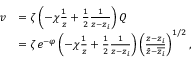<formula> <loc_0><loc_0><loc_500><loc_500>\begin{array} { r l } { v } & { = \zeta \left ( - \chi \frac { 1 } { z } + \frac { 1 } { 2 } \frac { 1 } { z - z _ { i } } \right ) Q } \\ & { = \zeta e ^ { - \varphi } \left ( - \chi \frac { 1 } { z } + \frac { 1 } { 2 } \frac { 1 } { z - z _ { i } } \right ) \left ( \frac { z - z _ { i } } { \bar { z } - \overline { { z _ { i } } } } \right ) ^ { 1 / 2 } , } \end{array}</formula> 